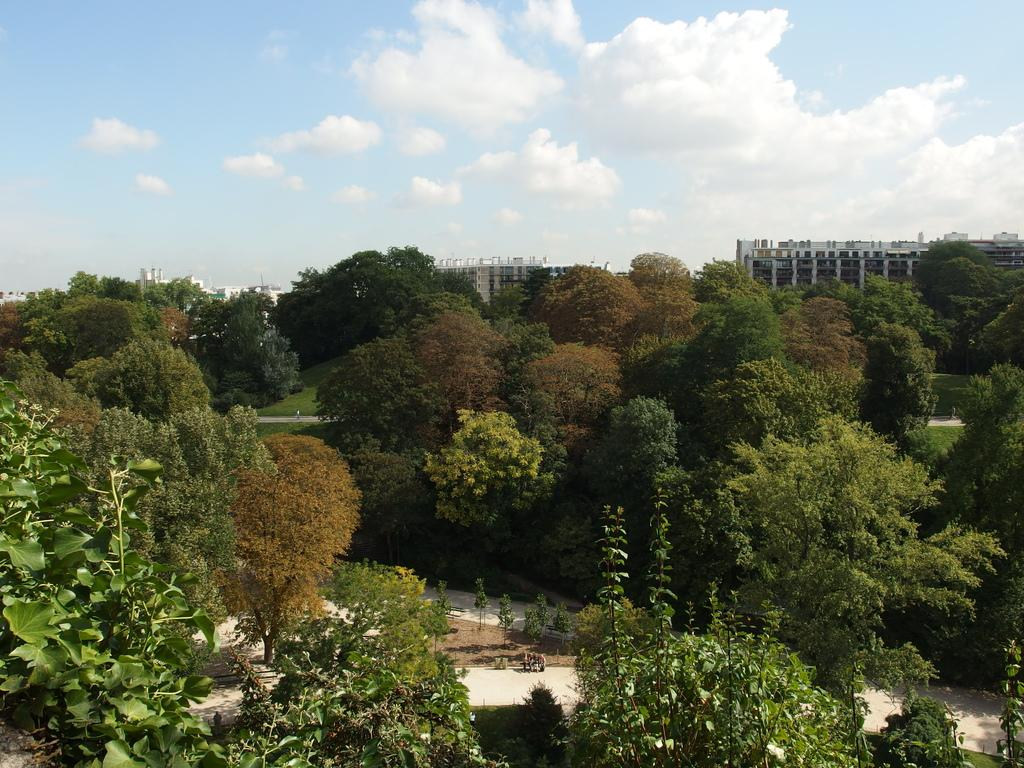What type of natural elements can be seen in the image? There are many trees and plants in the image. What type of man-made structures are visible in the image? There are footpaths and buildings in the image. What is visible in the background of the image? There are buildings in the background of the image. What is the condition of the sky in the image? The sky is cloudy and visible at the top of the image. Can you see any chalk or cobwebs in the image? There is no chalk or cobwebs present in the image. How many times has the fold been repeated in the image? There is no fold present in the image. 